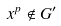<formula> <loc_0><loc_0><loc_500><loc_500>x ^ { p } \notin G ^ { \prime }</formula> 